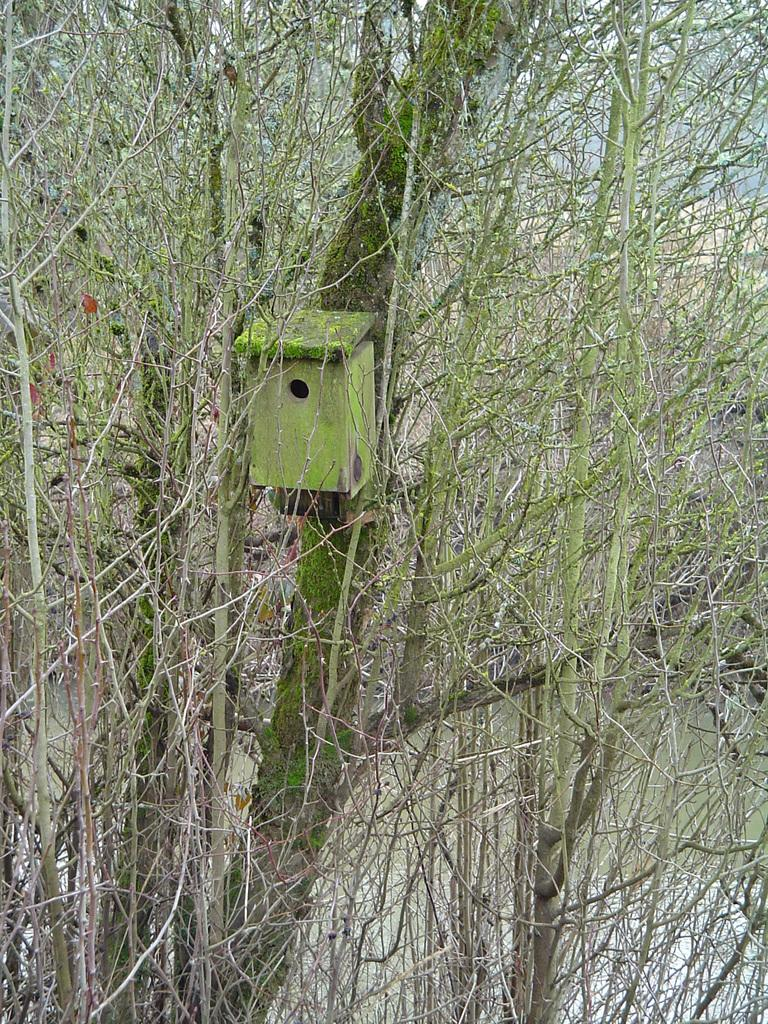What type of vegetation is present in the image? There are trees in the image. What object can be seen in the image besides the trees? There is a box in the image. What can be seen in the background of the image? There is a pond and grass in the background of the image. What word is written on the box in the image? There is no word written on the box in the image; it is just a plain box. 